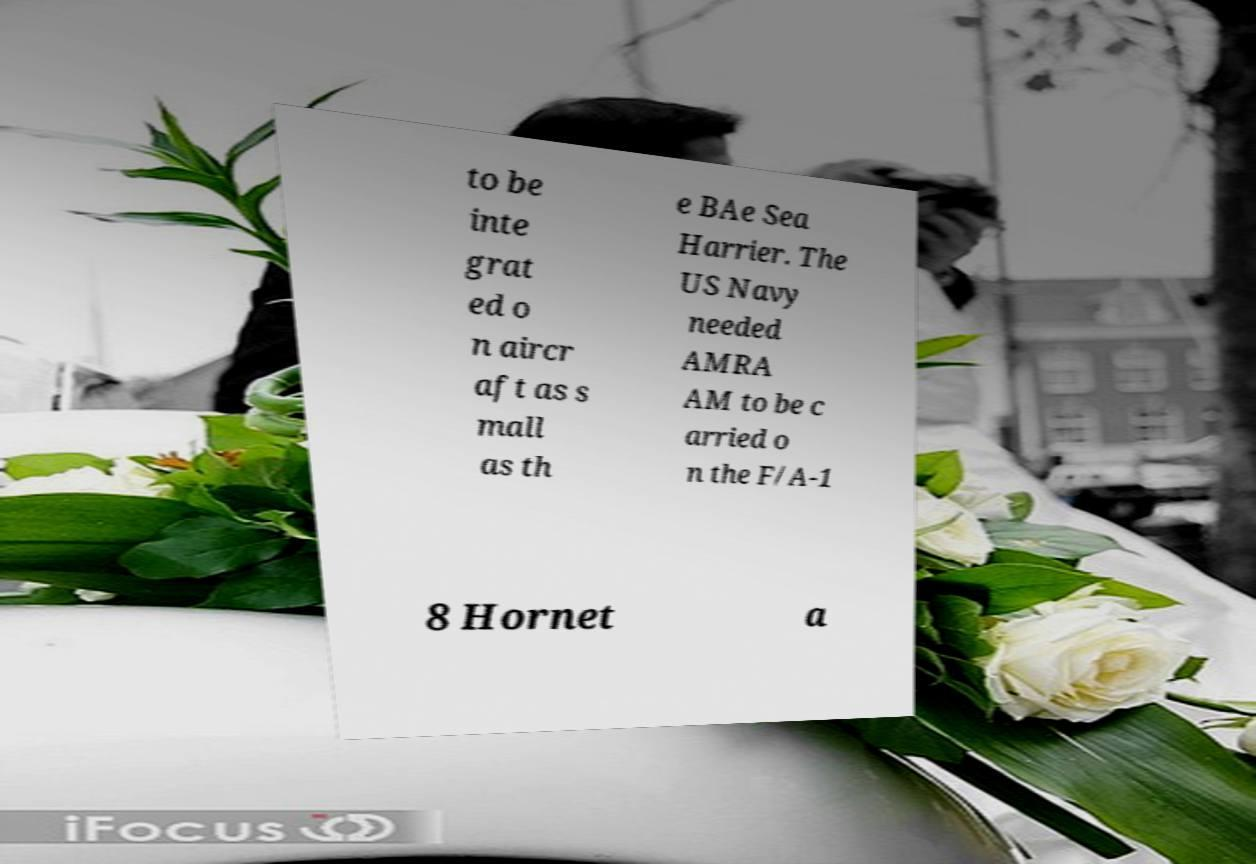Can you accurately transcribe the text from the provided image for me? to be inte grat ed o n aircr aft as s mall as th e BAe Sea Harrier. The US Navy needed AMRA AM to be c arried o n the F/A-1 8 Hornet a 